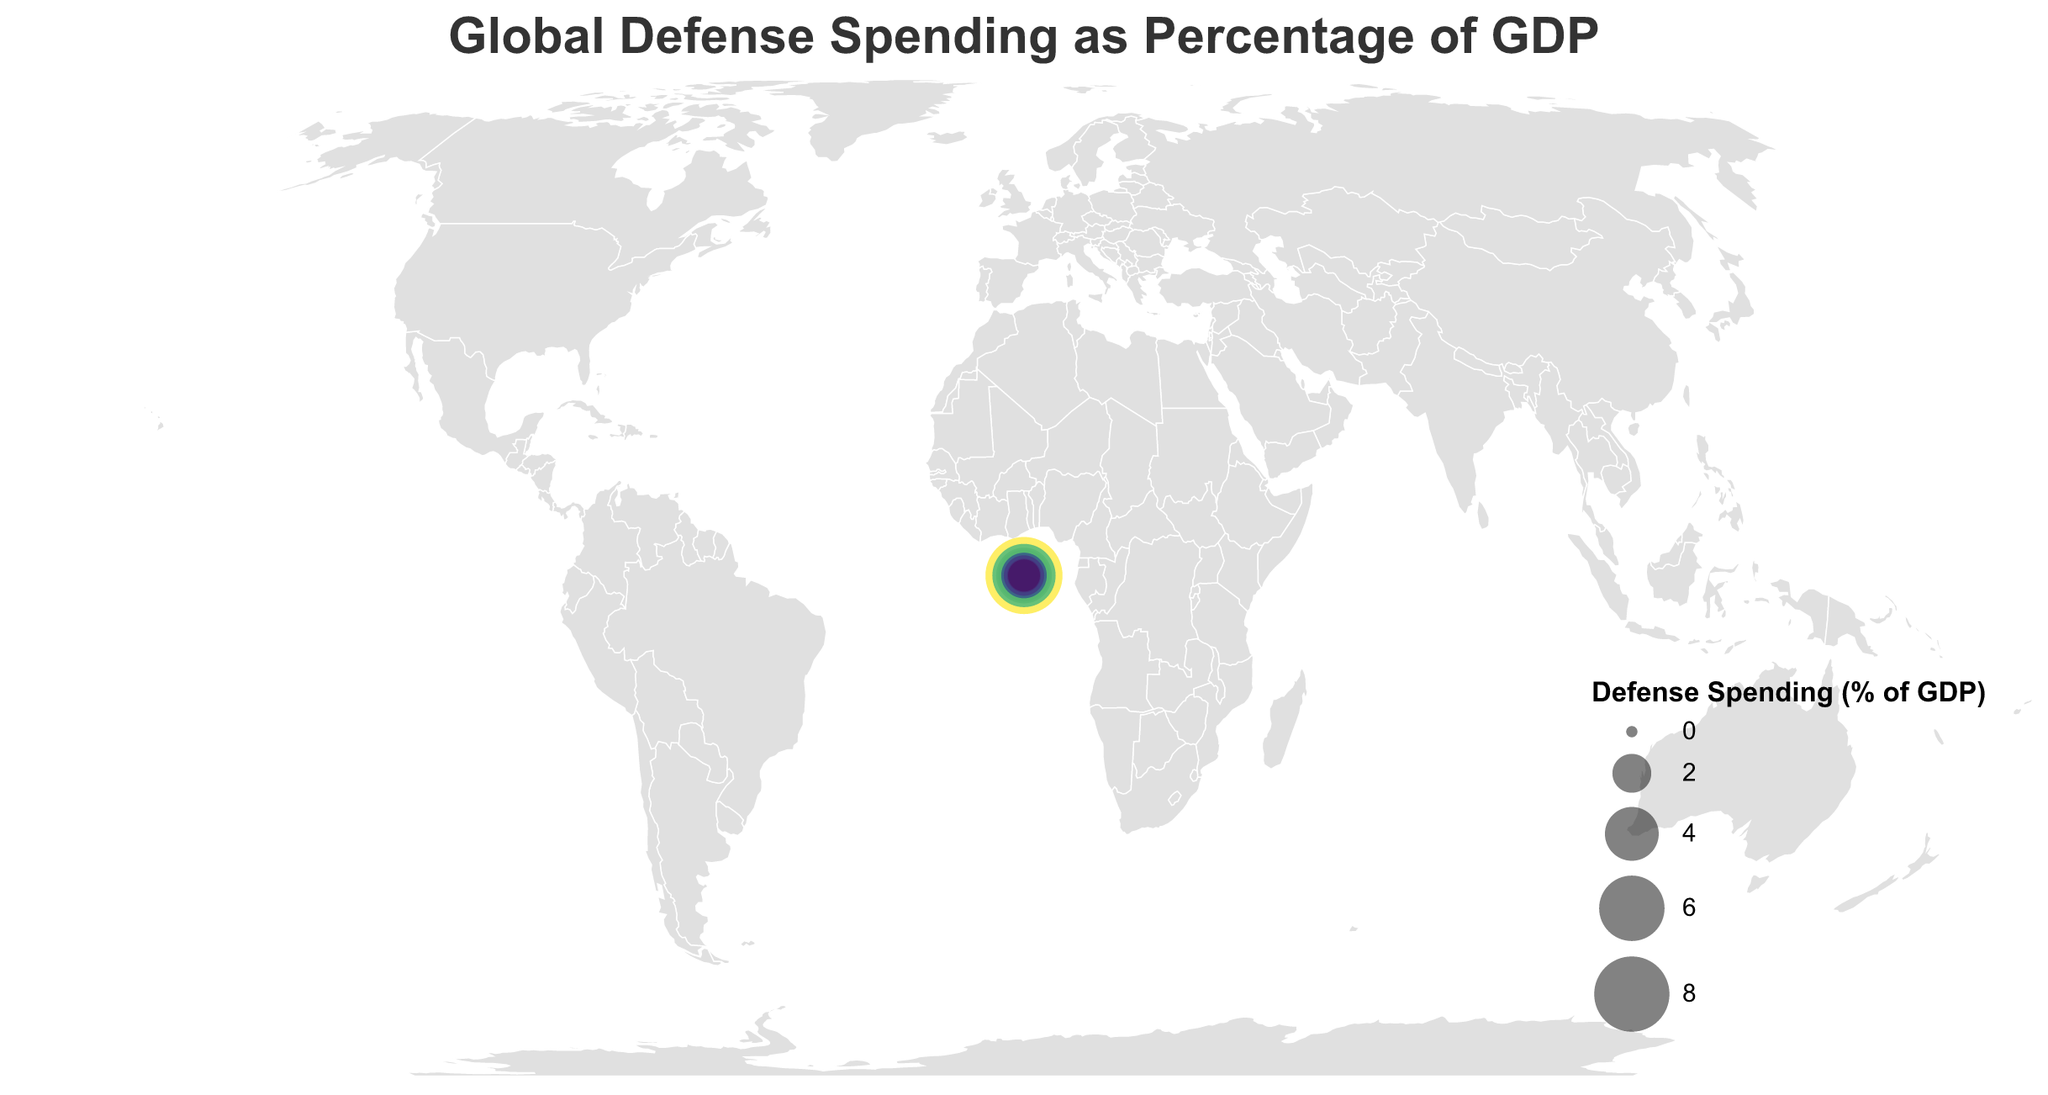Which country has the highest defense spending as a percentage of GDP? By observing the plot, the country with the largest circle size (and darkest color in a viridis color scheme) represents the highest percentage. Saudi Arabia has the highest defense spending percentage of GDP indicated by its very large circle and dark color.
Answer: Saudi Arabia What is the defense spending percentage for the United States? Locate the United States on the map and refer to the circle's size and tooltip information. The tooltip shows the defense spending for the United States is 3.7%.
Answer: 3.7% How does the defense spending percentage of Japan compare to that of Germany? Locate Japan and Germany on the map and compare their respective circle sizes and colors. Japan has 1.0% and Germany has 1.5%. Germany spends a higher percentage of its GDP on defense than Japan.
Answer: Germany has a higher percentage Which country has a defense spending percentage close to the United Kingdom? Locate the United Kingdom on the map (circle with 2.2%). Look for other countries with similar circle sizes and colors. Poland also has a 2.2% defense spending percentage.
Answer: Poland Rank the top three countries by their defense spending percentage. From the plot, observe the countries with the largest circle sizes. Saudi Arabia (8.4%), Israel (5.6%), and Russia (4.3%) are the top three countries.
Answer: Saudi Arabia, Israel, Russia Which country in Europe has the lowest defense spending percentage? Focus on European countries and identify the one with the smallest circle size and lightest color. Spain has the lowest defense spending percentage in Europe at 1.3%.
Answer: Spain How does Turkey's defense spending compare to South Korea’s? Locate both Turkey and South Korea on the map and compare the circle sizes. Both countries have a spending percentage of 2.8% of GDP.
Answer: Equal Identify the countries with defense spending percentages between 1.0% and 2.0%. Look for countries with moderately sized circles that have percentages within the specified range. These countries are China (1.7%), Germany (1.5%), Canada (1.4%), Brazil (1.4%), Netherlands (1.4%), Spain (1.3%), and Sweden (1.3%).
Answer: China, Germany, Canada, Brazil, Netherlands, Spain, Sweden Which countries have a defense spending percentage above 4%? Observe the circles with a greater size and darkest colors for percentages above 4%. These countries are Saudi Arabia (8.4%), Israel (5.6%), and Russia (4.3%).
Answer: Saudi Arabia, Israel, Russia 